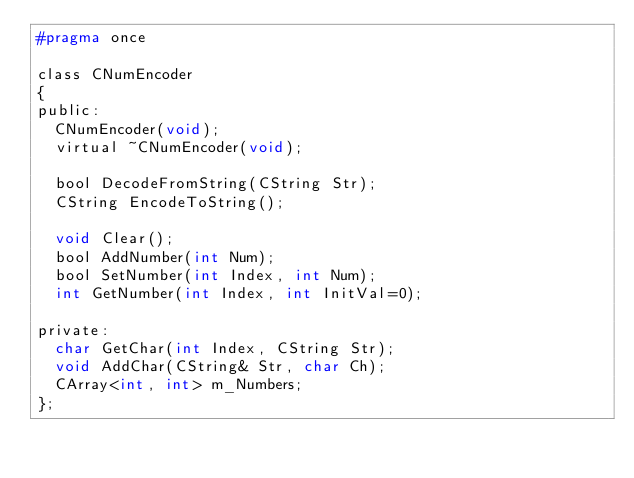Convert code to text. <code><loc_0><loc_0><loc_500><loc_500><_C_>#pragma once

class CNumEncoder
{
public:
	CNumEncoder(void);
	virtual ~CNumEncoder(void);

	bool DecodeFromString(CString Str);
	CString EncodeToString();

	void Clear();
	bool AddNumber(int Num);
	bool SetNumber(int Index, int Num);
	int GetNumber(int Index, int InitVal=0);

private:
	char GetChar(int Index, CString Str);
	void AddChar(CString& Str, char Ch);
	CArray<int, int> m_Numbers;
};
</code> 